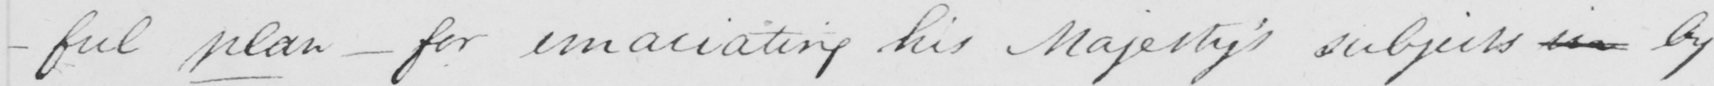Can you tell me what this handwritten text says? -ful plan - for emaciating his Majesty ' s subjects in by 